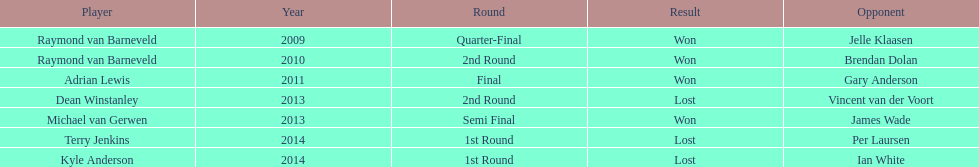How many champions were from norway? 0. Would you mind parsing the complete table? {'header': ['Player', 'Year', 'Round', 'Result', 'Opponent'], 'rows': [['Raymond van Barneveld', '2009', 'Quarter-Final', 'Won', 'Jelle Klaasen'], ['Raymond van Barneveld', '2010', '2nd Round', 'Won', 'Brendan Dolan'], ['Adrian Lewis', '2011', 'Final', 'Won', 'Gary Anderson'], ['Dean Winstanley', '2013', '2nd Round', 'Lost', 'Vincent van der Voort'], ['Michael van Gerwen', '2013', 'Semi Final', 'Won', 'James Wade'], ['Terry Jenkins', '2014', '1st Round', 'Lost', 'Per Laursen'], ['Kyle Anderson', '2014', '1st Round', 'Lost', 'Ian White']]} 